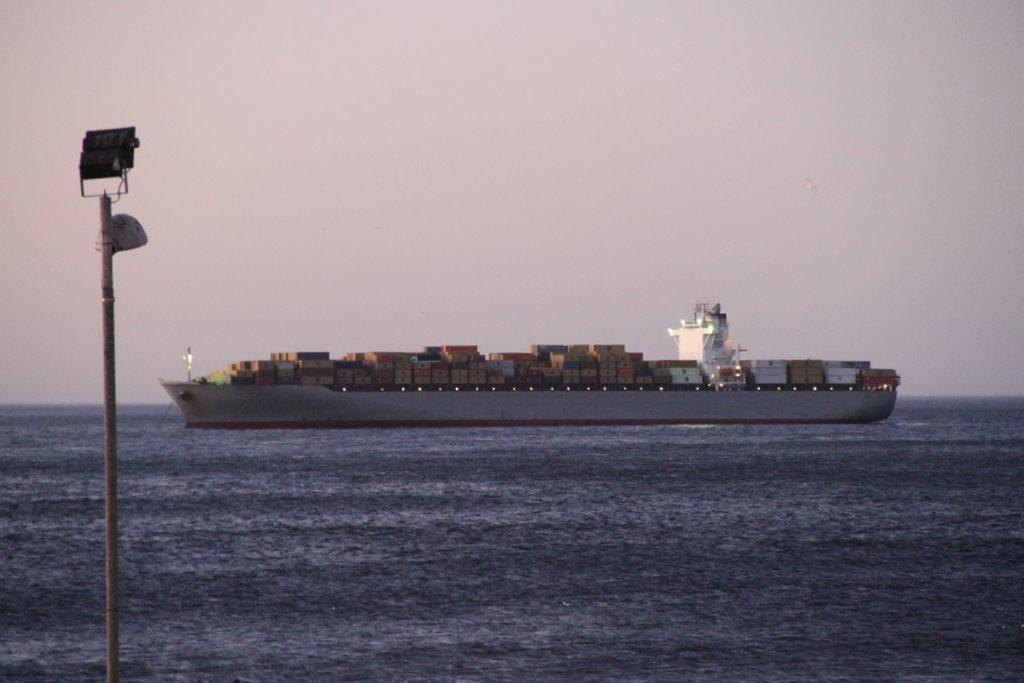What is the main subject of the image? The main subject of the image is a boat. What can be observed about the boat's contents? The boat has many containers. Where is the boat located? The boat is on the water. What is present to the left of the boat? There is a pole to the left of the boat. What can be seen in the background of the image? The sky is visible in the background of the image. What type of substance is being transported by the cannon on the boat? There is no cannon present on the boat in the image. How many snakes are visible on the boat in the image? There are no snakes visible on the boat in the image. 